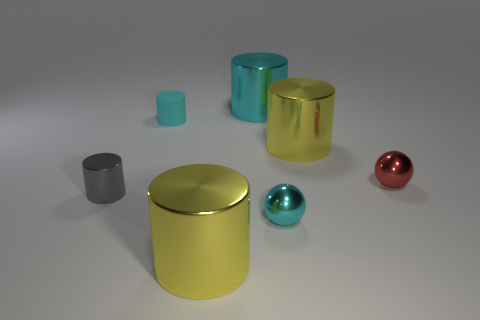How many small objects are either cyan rubber cylinders or cyan things?
Offer a terse response. 2. What number of metal things are the same shape as the rubber object?
Give a very brief answer. 4. There is a small rubber thing; is its shape the same as the tiny metal object that is left of the tiny cyan matte cylinder?
Ensure brevity in your answer.  Yes. How many tiny cyan balls are to the right of the red metallic object?
Provide a succinct answer. 0. Are there any yellow shiny cubes of the same size as the red thing?
Make the answer very short. No. Is the shape of the yellow metallic object that is in front of the tiny gray metal cylinder the same as  the big cyan metallic thing?
Offer a very short reply. Yes. The tiny metal cylinder has what color?
Offer a very short reply. Gray. What is the shape of the tiny object that is the same color as the matte cylinder?
Offer a terse response. Sphere. Are there any large metal cylinders?
Your answer should be very brief. Yes. There is a gray cylinder that is made of the same material as the tiny red sphere; what is its size?
Make the answer very short. Small. 